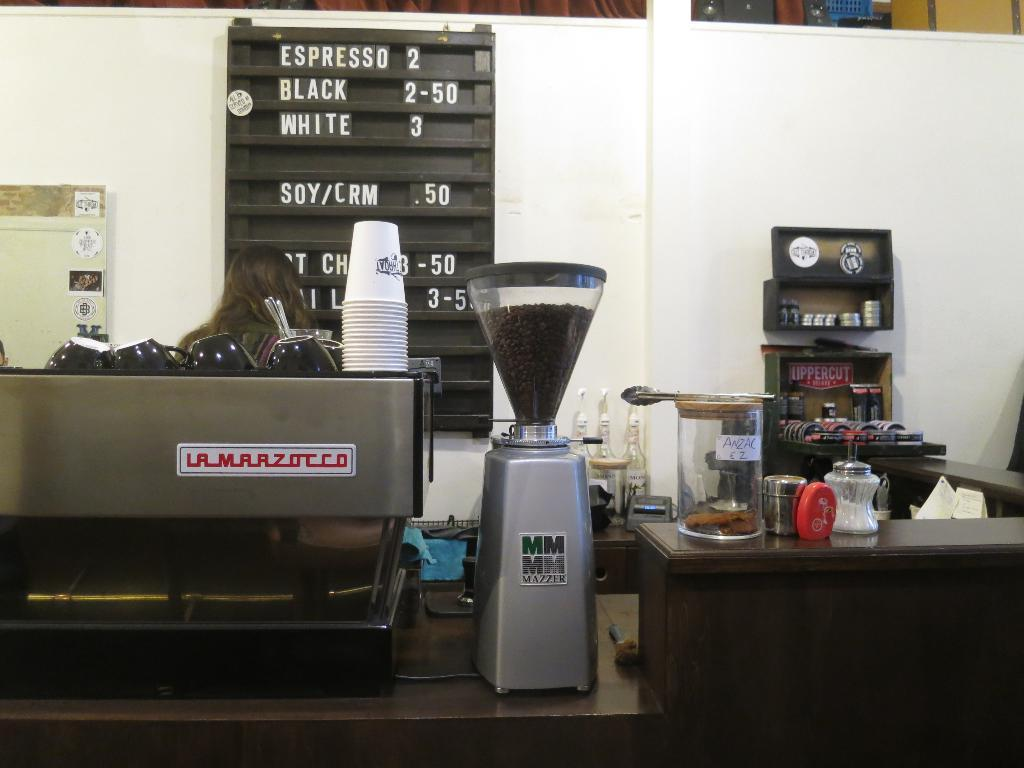Provide a one-sentence caption for the provided image. A menu in a coffee shop offering different types of coffee. 